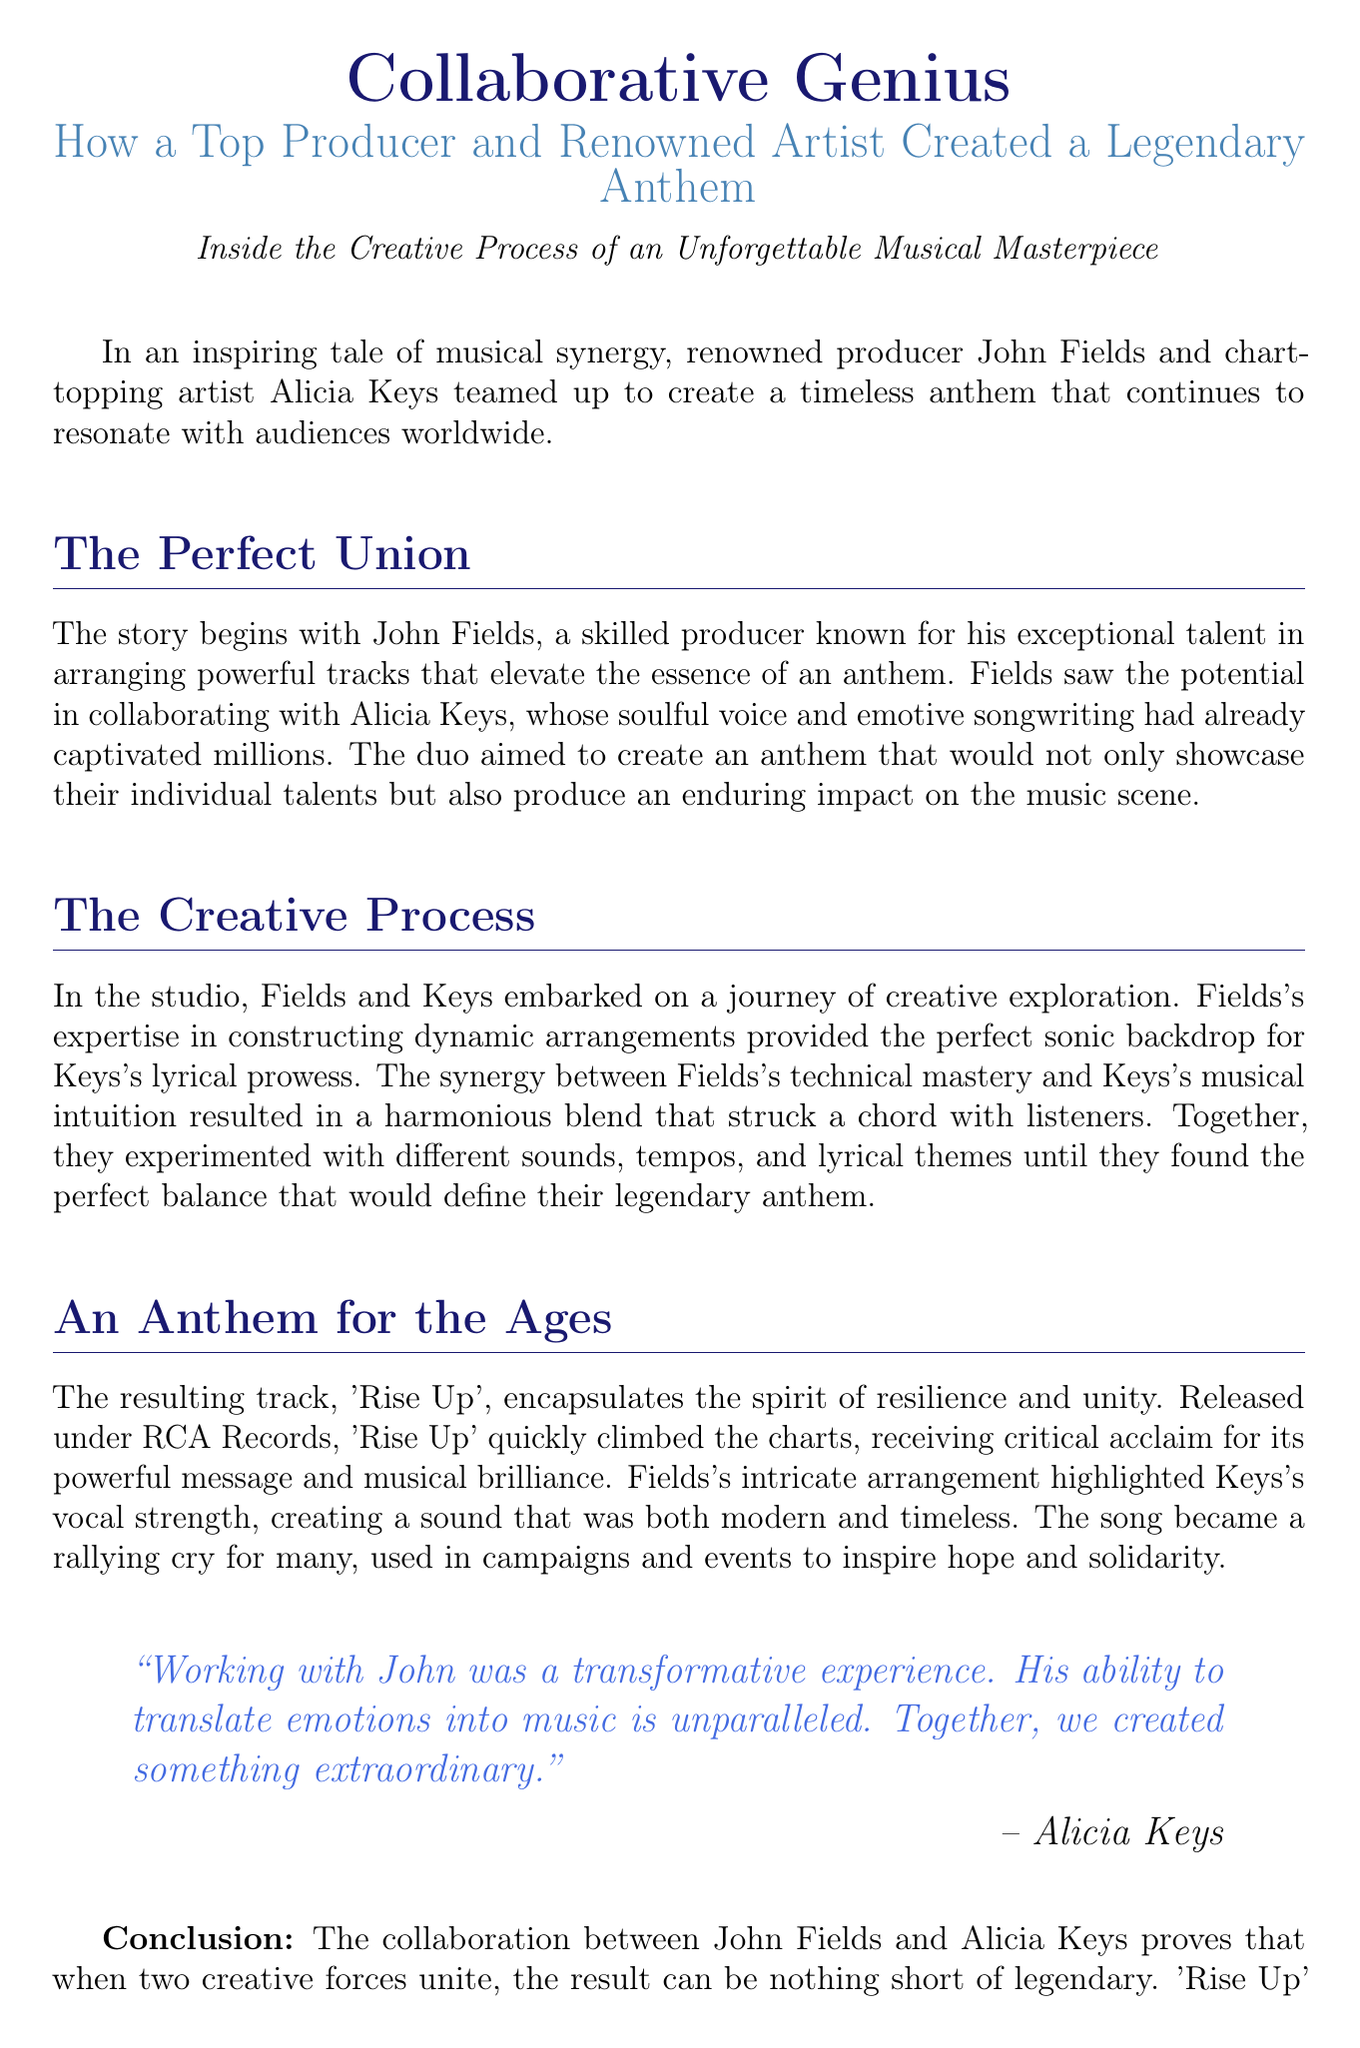What are the names of the collaborators? The document mentions John Fields and Alicia Keys as the collaborators who created the anthem.
Answer: John Fields and Alicia Keys What is the title of the anthem? The document specifies the title of the anthem created by the duo as 'Rise Up'.
Answer: 'Rise Up' What record label released the anthem? The document states that the anthem was released under RCA Records.
Answer: RCA Records What theme does 'Rise Up' encapsulate? The document highlights that the anthem 'Rise Up' encapsulates the spirit of resilience and unity.
Answer: Resilience and unity What was Alicia Keys's opinion on working with John Fields? The document includes Alicia Keys's quote expressing her view on the experience of working with John Fields.
Answer: Transformative experience What key aspect did John Fields contribute to the collaboration? The document notes that John Fields's expertise involved constructing dynamic arrangements which enhanced the music.
Answer: Dynamic arrangements When was the anthem 'Rise Up' released? The document does not specify the actual release date, focusing instead on the anthem's impact and success.
Answer: Not specified What is the primary focus of this press release? The document centers on the collaboration between the two artists and the creation process of the anthem.
Answer: Collaboration and creation process What genre does the anthem 'Rise Up' represent? The document does not explicitly mention the genre of the anthem, focusing instead on its emotional and lyrical themes.
Answer: Not specified 